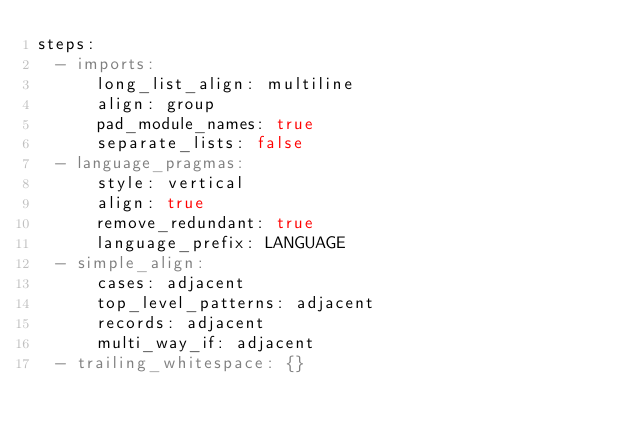<code> <loc_0><loc_0><loc_500><loc_500><_YAML_>steps:
  - imports:
      long_list_align: multiline
      align: group
      pad_module_names: true
      separate_lists: false
  - language_pragmas:
      style: vertical
      align: true
      remove_redundant: true
      language_prefix: LANGUAGE
  - simple_align:
      cases: adjacent
      top_level_patterns: adjacent
      records: adjacent
      multi_way_if: adjacent
  - trailing_whitespace: {}
</code> 